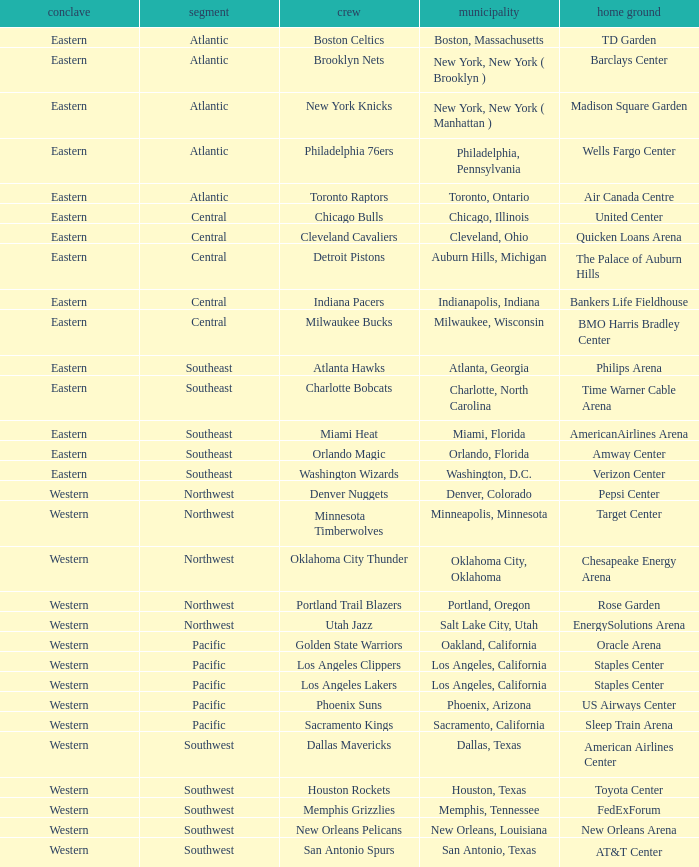Which team is in the Southeast with a home at Philips Arena? Atlanta Hawks. 